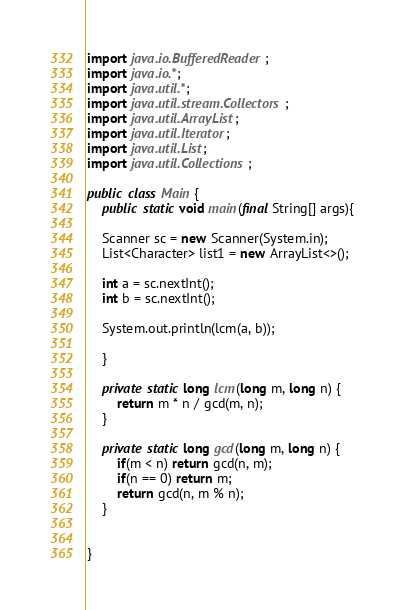Convert code to text. <code><loc_0><loc_0><loc_500><loc_500><_Java_>import java.io.BufferedReader;
import java.io.*;
import java.util.*;
import java.util.stream.Collectors;
import java.util.ArrayList;
import java.util.Iterator;
import java.util.List;
import java.util.Collections;

public class Main {
	public static void main(final String[] args){
    
    Scanner sc = new Scanner(System.in);
    List<Character> list1 = new ArrayList<>();

    int a = sc.nextInt();
    int b = sc.nextInt();
    
    System.out.println(lcm(a, b));

    }

    private static long lcm(long m, long n) {
        return m * n / gcd(m, n);
    }

    private static long gcd(long m, long n) {
        if(m < n) return gcd(n, m);
        if(n == 0) return m;
        return gcd(n, m % n);
    }


}</code> 